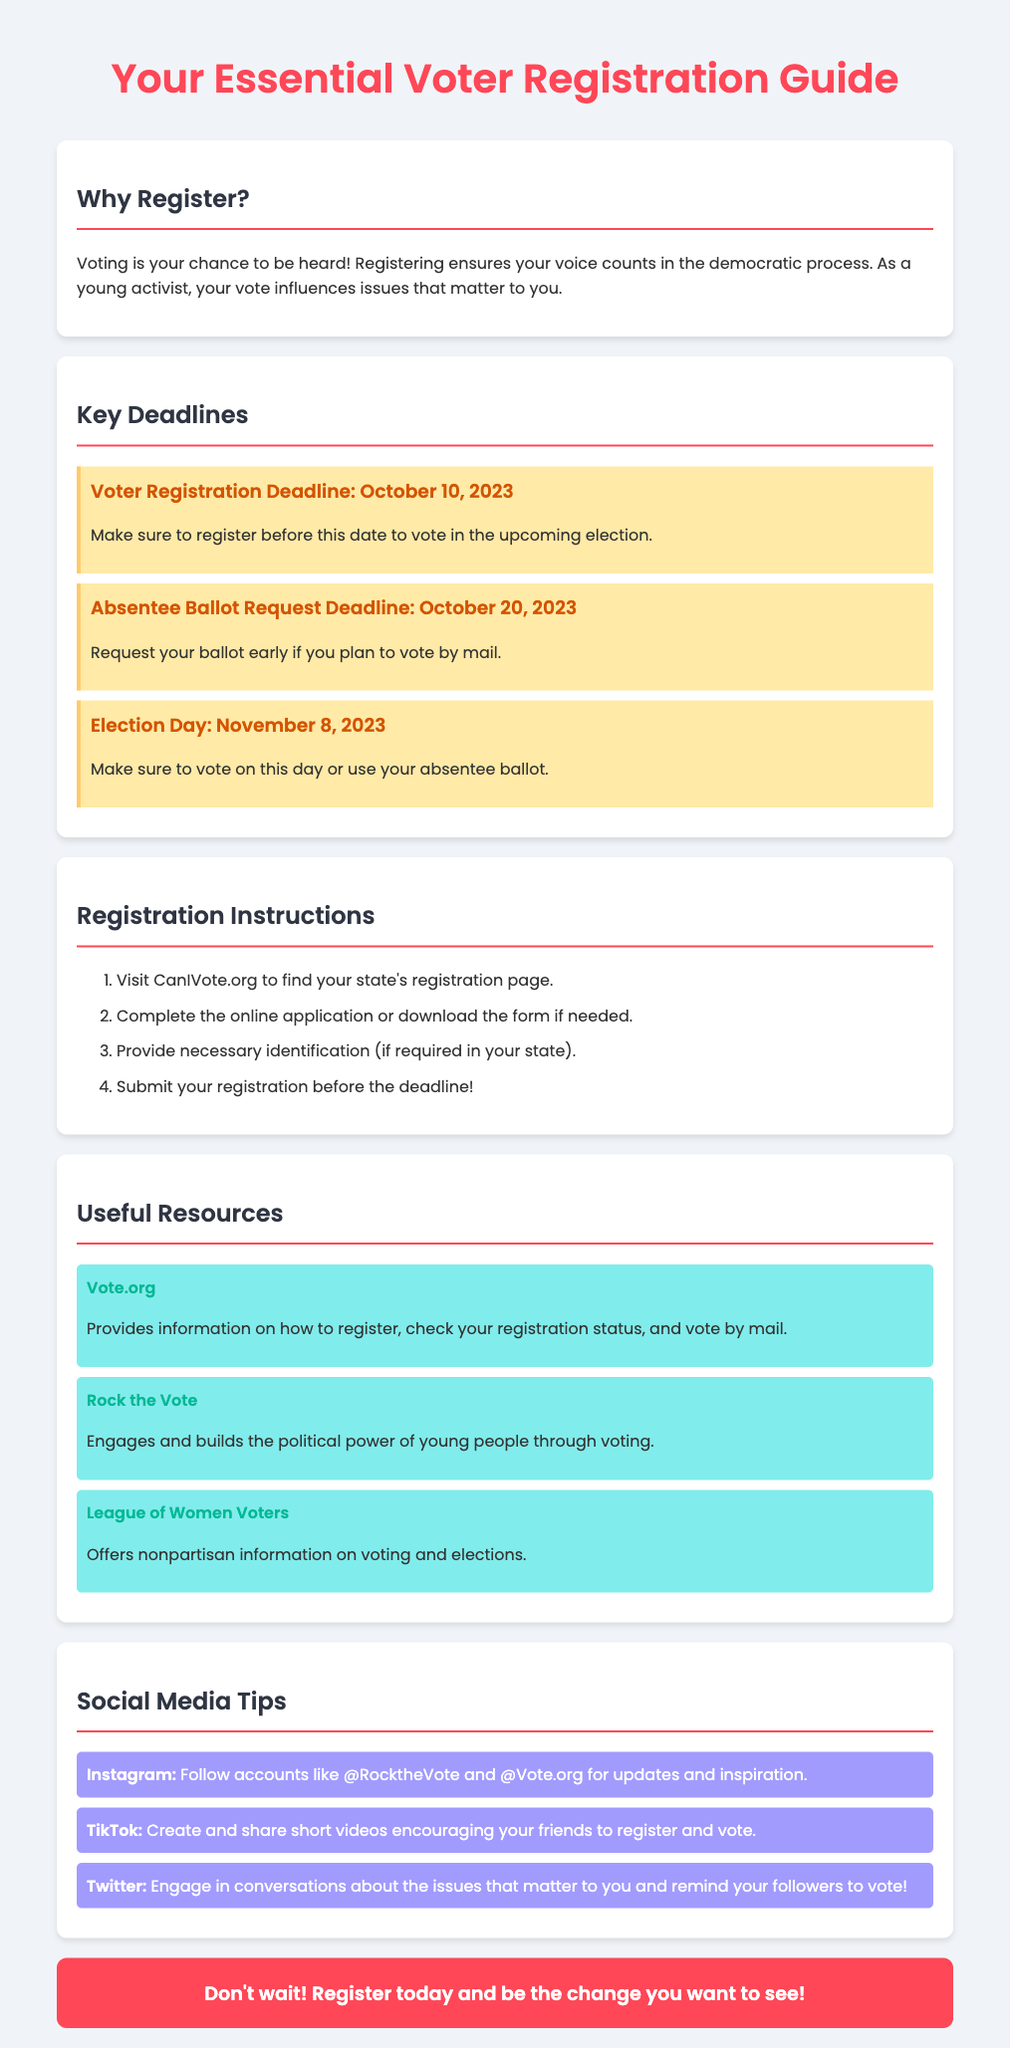What is the title of the document? The title of the document is indicated at the top of the rendered page
Answer: Your Essential Voter Registration Guide What is the voter registration deadline? The voter registration deadline is clearly stated in the deadlines section of the document
Answer: October 10, 2023 What is one resource mentioned for voter registration? The document lists multiple resources for voter registration; one example is found in the useful resources section
Answer: Vote.org How many key deadlines are listed in the document? The document specifies three key deadlines related to voter registration and voting
Answer: Three Which social media platform suggests creating videos to encourage voting? The social media tips section of the document mentions this specific action on a particular platform
Answer: TikTok Why should young people register to vote? The document provides a rationale in the first section on why voting is important
Answer: Your voice counts What is the last day to request an absentee ballot? The document provides a date for this specific action
Answer: October 20, 2023 What color is used for the call-to-action box? The styling of the document indicates specific colors used for various sections, including the call-to-action
Answer: Red What kind of information does the League of Women Voters provide? The document describes the type of information offered by this resource
Answer: Nonpartisan information 